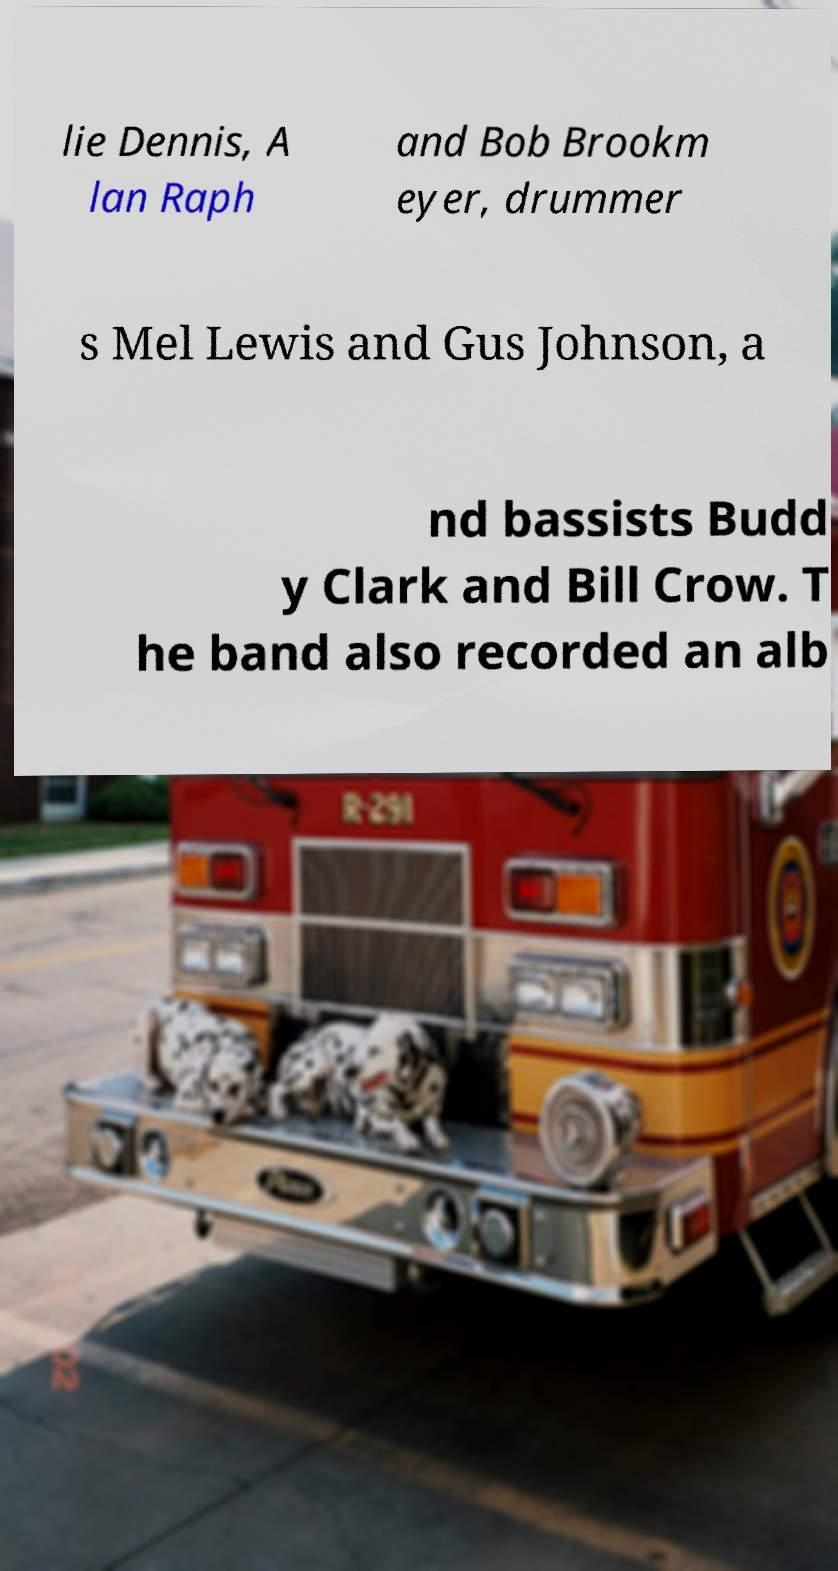Please read and relay the text visible in this image. What does it say? lie Dennis, A lan Raph and Bob Brookm eyer, drummer s Mel Lewis and Gus Johnson, a nd bassists Budd y Clark and Bill Crow. T he band also recorded an alb 